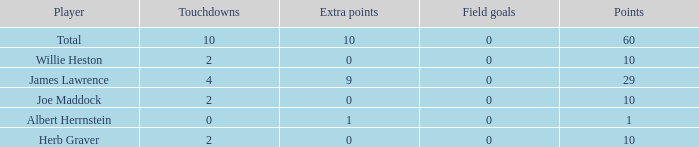What is the smallest number of field goals for players with 4 touchdowns and less than 9 extra points? None. 